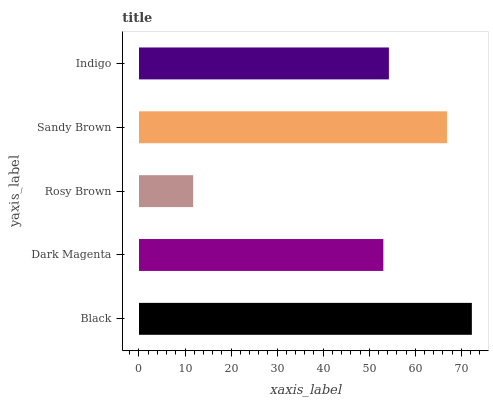Is Rosy Brown the minimum?
Answer yes or no. Yes. Is Black the maximum?
Answer yes or no. Yes. Is Dark Magenta the minimum?
Answer yes or no. No. Is Dark Magenta the maximum?
Answer yes or no. No. Is Black greater than Dark Magenta?
Answer yes or no. Yes. Is Dark Magenta less than Black?
Answer yes or no. Yes. Is Dark Magenta greater than Black?
Answer yes or no. No. Is Black less than Dark Magenta?
Answer yes or no. No. Is Indigo the high median?
Answer yes or no. Yes. Is Indigo the low median?
Answer yes or no. Yes. Is Sandy Brown the high median?
Answer yes or no. No. Is Rosy Brown the low median?
Answer yes or no. No. 